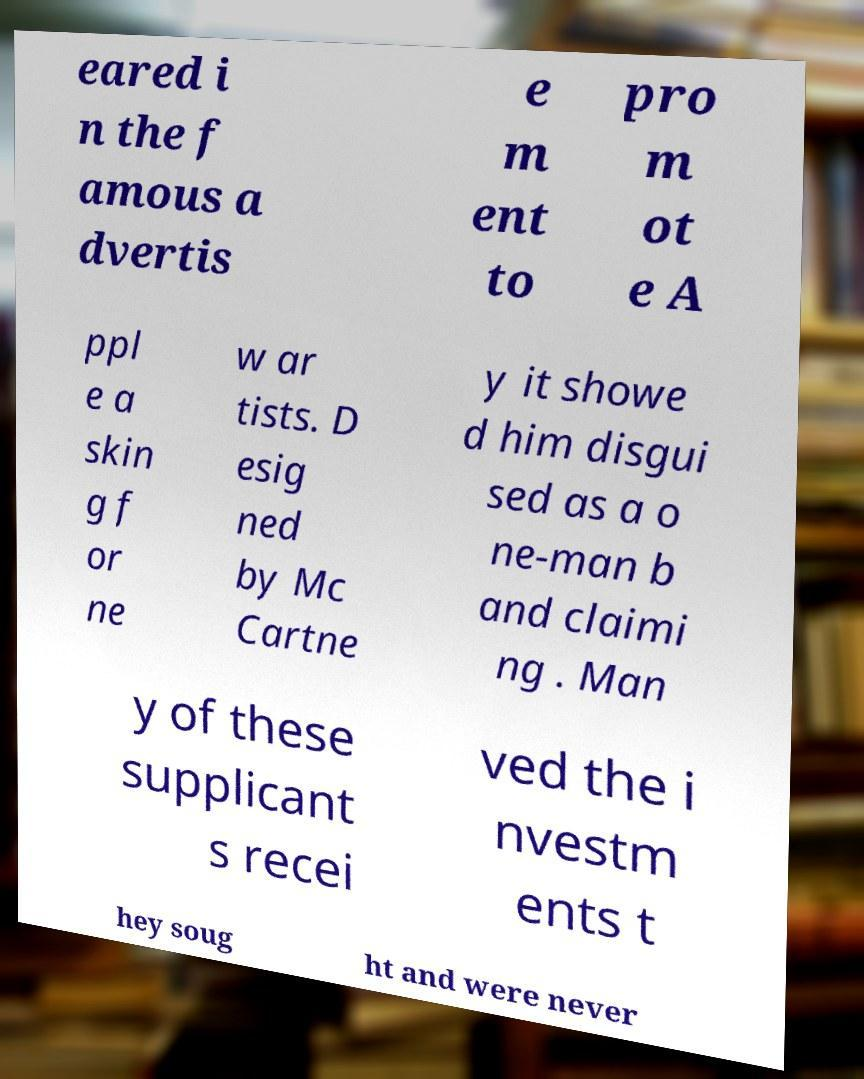I need the written content from this picture converted into text. Can you do that? eared i n the f amous a dvertis e m ent to pro m ot e A ppl e a skin g f or ne w ar tists. D esig ned by Mc Cartne y it showe d him disgui sed as a o ne-man b and claimi ng . Man y of these supplicant s recei ved the i nvestm ents t hey soug ht and were never 